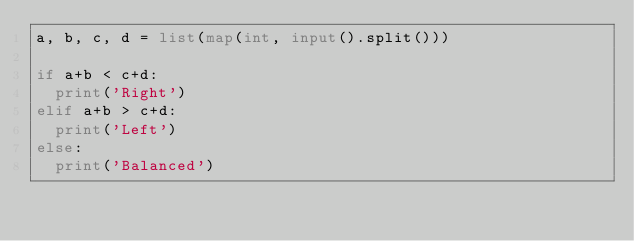<code> <loc_0><loc_0><loc_500><loc_500><_Python_>a, b, c, d = list(map(int, input().split()))

if a+b < c+d:
  print('Right')
elif a+b > c+d:
  print('Left')
else:
  print('Balanced')
</code> 